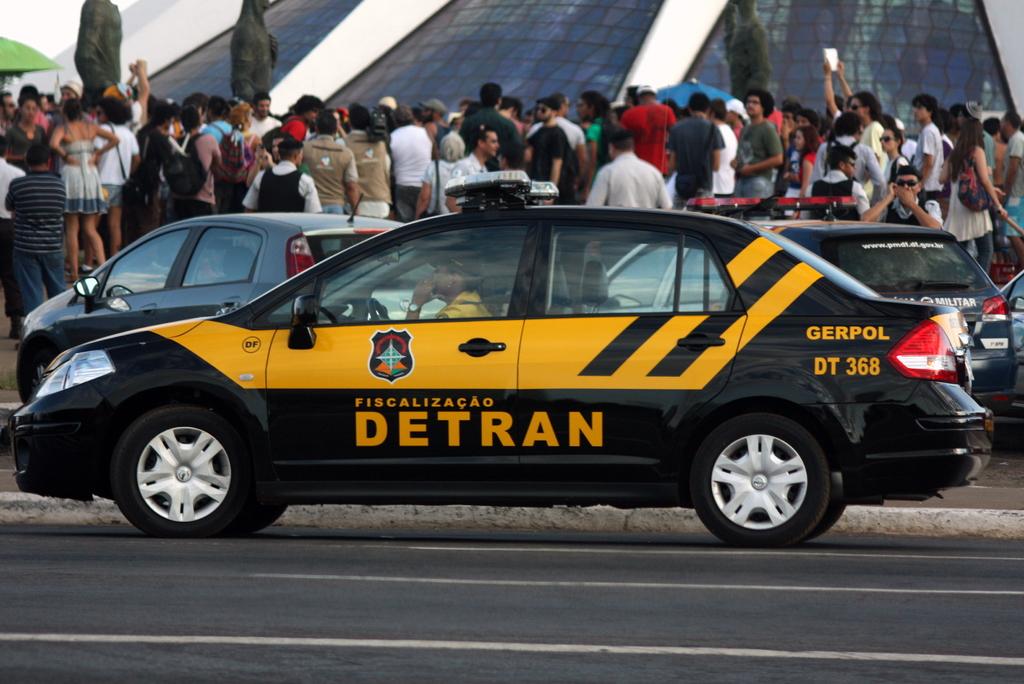What is the number near the rear of the car?
Provide a short and direct response. 368. What is written on the side of the car?
Provide a short and direct response. Detran. 